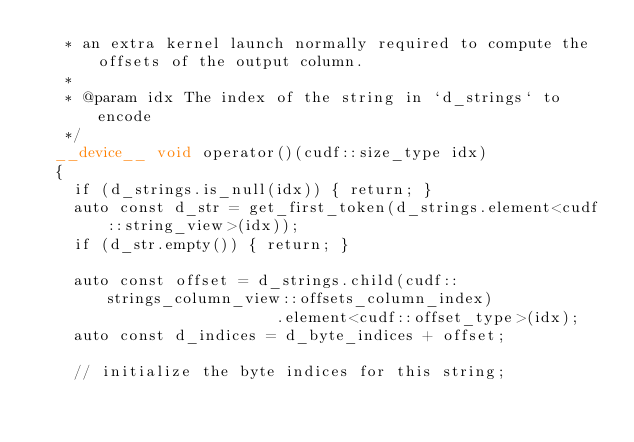<code> <loc_0><loc_0><loc_500><loc_500><_Cuda_>   * an extra kernel launch normally required to compute the offsets of the output column.
   *
   * @param idx The index of the string in `d_strings` to encode
   */
  __device__ void operator()(cudf::size_type idx)
  {
    if (d_strings.is_null(idx)) { return; }
    auto const d_str = get_first_token(d_strings.element<cudf::string_view>(idx));
    if (d_str.empty()) { return; }

    auto const offset = d_strings.child(cudf::strings_column_view::offsets_column_index)
                          .element<cudf::offset_type>(idx);
    auto const d_indices = d_byte_indices + offset;

    // initialize the byte indices for this string;</code> 